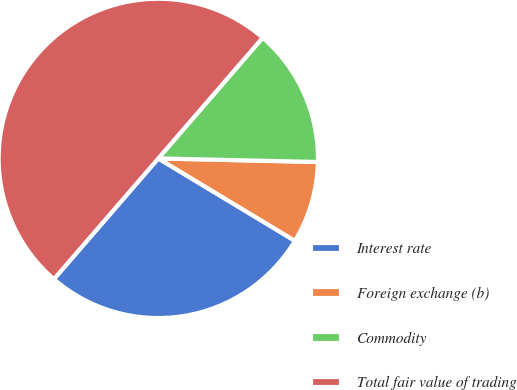Convert chart to OTSL. <chart><loc_0><loc_0><loc_500><loc_500><pie_chart><fcel>Interest rate<fcel>Foreign exchange (b)<fcel>Commodity<fcel>Total fair value of trading<nl><fcel>27.71%<fcel>8.28%<fcel>14.01%<fcel>50.0%<nl></chart> 